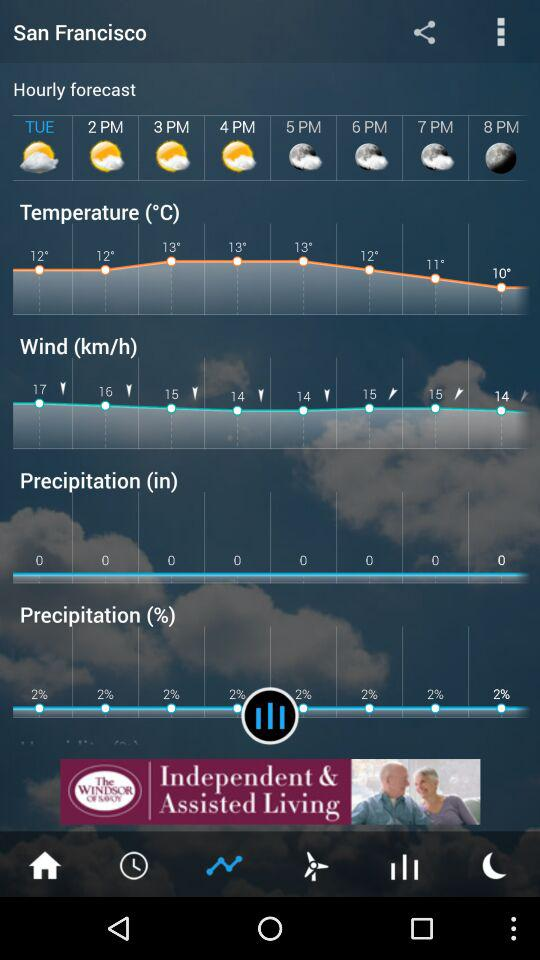What is the mentioned location? The location is San Francisco. 